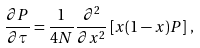Convert formula to latex. <formula><loc_0><loc_0><loc_500><loc_500>\frac { \partial P } { \partial \tau } = \frac { 1 } { 4 N } \frac { \partial ^ { 2 } } { \partial x ^ { 2 } } \left [ x ( 1 - x ) P \right ] \, ,</formula> 